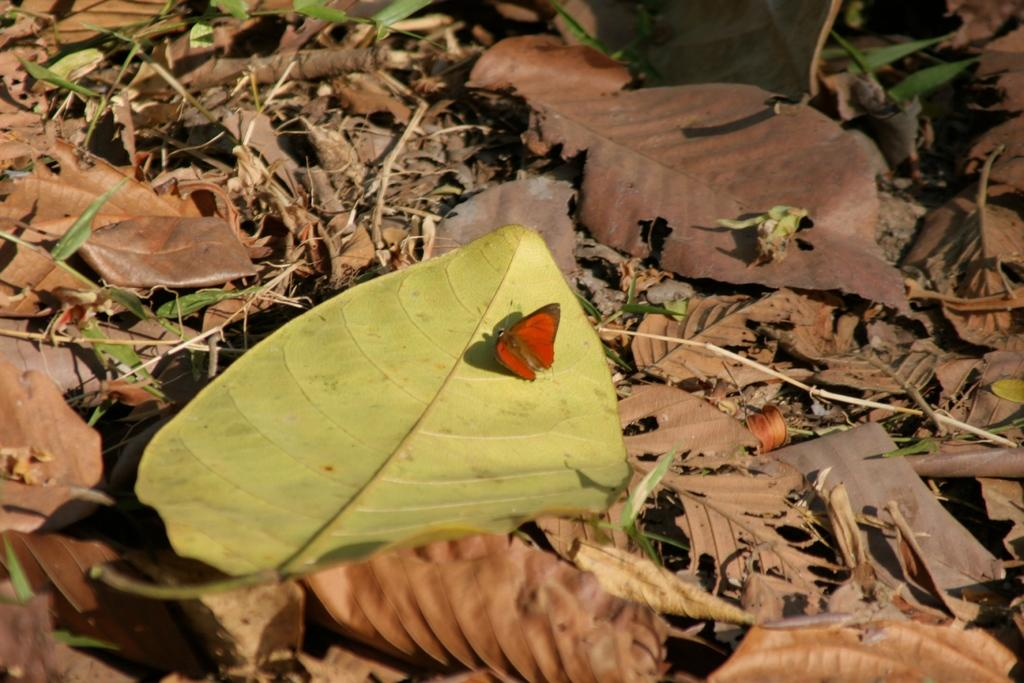What is on the ground in the image? There are leaves on the ground in the image. What type of insect can be seen in the image? There is a butterfly in the image. Where is the butterfly located in the image? The butterfly is in the center of the image. What color is the butterfly? The butterfly is red in color. What is the name of the rod used to hold the screw in the image? There is no rod or screw present in the image; it features leaves on the ground and a red butterfly. 